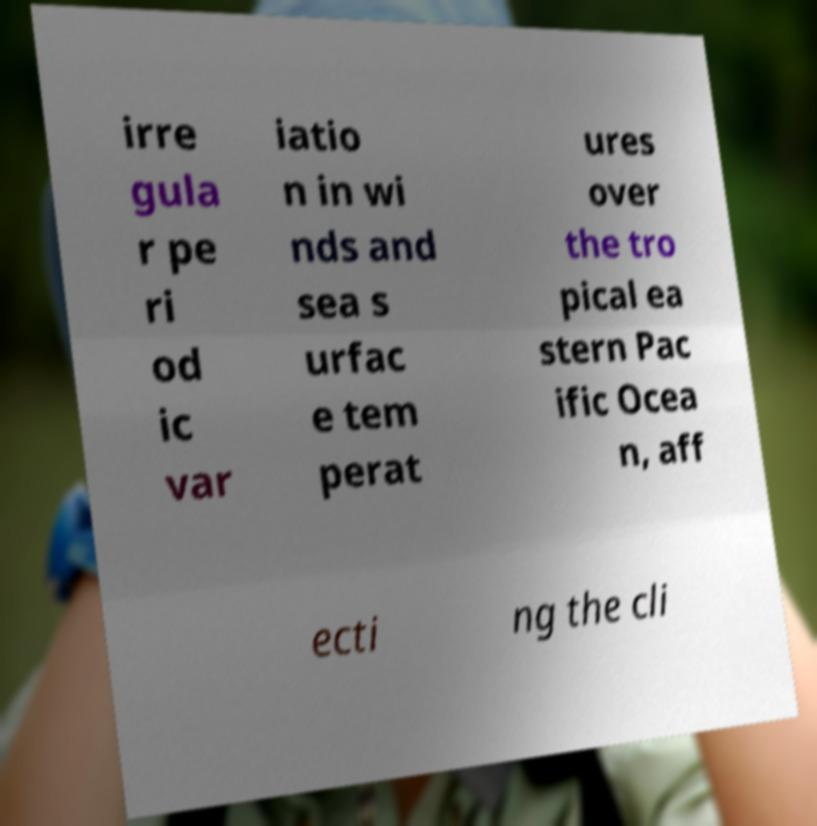Can you accurately transcribe the text from the provided image for me? irre gula r pe ri od ic var iatio n in wi nds and sea s urfac e tem perat ures over the tro pical ea stern Pac ific Ocea n, aff ecti ng the cli 